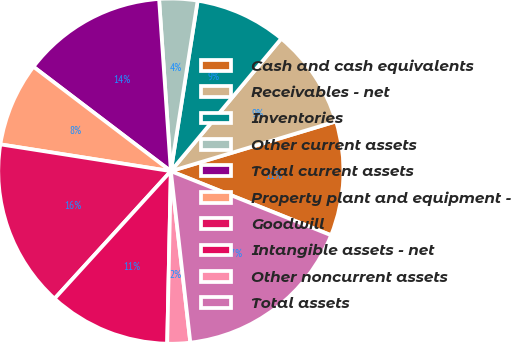Convert chart to OTSL. <chart><loc_0><loc_0><loc_500><loc_500><pie_chart><fcel>Cash and cash equivalents<fcel>Receivables - net<fcel>Inventories<fcel>Other current assets<fcel>Total current assets<fcel>Property plant and equipment -<fcel>Goodwill<fcel>Intangible assets - net<fcel>Other noncurrent assets<fcel>Total assets<nl><fcel>10.71%<fcel>9.29%<fcel>8.57%<fcel>3.57%<fcel>13.57%<fcel>7.86%<fcel>15.71%<fcel>11.43%<fcel>2.14%<fcel>17.14%<nl></chart> 